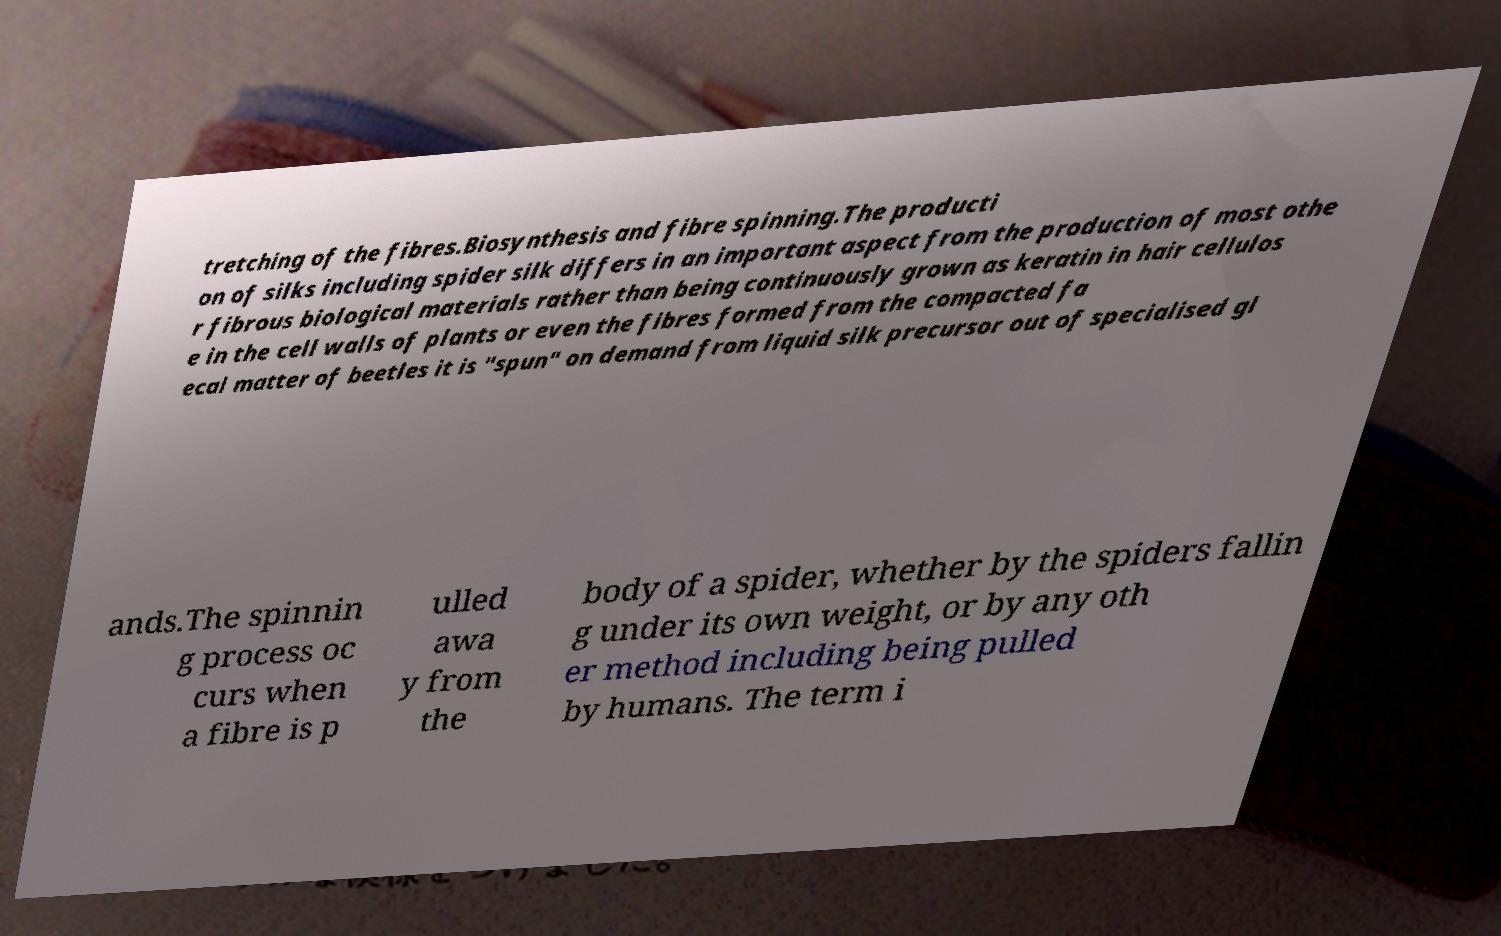Can you accurately transcribe the text from the provided image for me? tretching of the fibres.Biosynthesis and fibre spinning.The producti on of silks including spider silk differs in an important aspect from the production of most othe r fibrous biological materials rather than being continuously grown as keratin in hair cellulos e in the cell walls of plants or even the fibres formed from the compacted fa ecal matter of beetles it is "spun" on demand from liquid silk precursor out of specialised gl ands.The spinnin g process oc curs when a fibre is p ulled awa y from the body of a spider, whether by the spiders fallin g under its own weight, or by any oth er method including being pulled by humans. The term i 